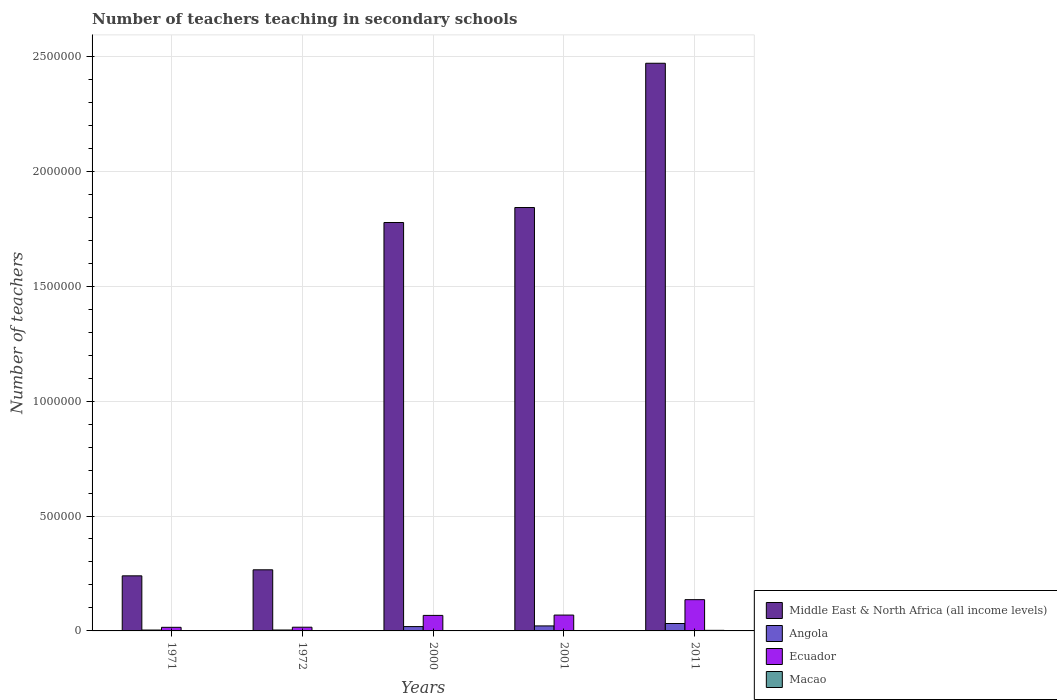How many groups of bars are there?
Provide a short and direct response. 5. Are the number of bars per tick equal to the number of legend labels?
Ensure brevity in your answer.  Yes. Are the number of bars on each tick of the X-axis equal?
Your answer should be very brief. Yes. What is the number of teachers teaching in secondary schools in Ecuador in 1971?
Your response must be concise. 1.57e+04. Across all years, what is the maximum number of teachers teaching in secondary schools in Angola?
Offer a terse response. 3.23e+04. Across all years, what is the minimum number of teachers teaching in secondary schools in Macao?
Your response must be concise. 668. In which year was the number of teachers teaching in secondary schools in Macao maximum?
Provide a short and direct response. 2011. What is the total number of teachers teaching in secondary schools in Macao in the graph?
Ensure brevity in your answer.  7018. What is the difference between the number of teachers teaching in secondary schools in Ecuador in 2001 and that in 2011?
Ensure brevity in your answer.  -6.71e+04. What is the difference between the number of teachers teaching in secondary schools in Middle East & North Africa (all income levels) in 2011 and the number of teachers teaching in secondary schools in Macao in 2000?
Your answer should be very brief. 2.47e+06. What is the average number of teachers teaching in secondary schools in Macao per year?
Keep it short and to the point. 1403.6. In the year 2001, what is the difference between the number of teachers teaching in secondary schools in Angola and number of teachers teaching in secondary schools in Ecuador?
Make the answer very short. -4.71e+04. In how many years, is the number of teachers teaching in secondary schools in Middle East & North Africa (all income levels) greater than 1300000?
Make the answer very short. 3. What is the ratio of the number of teachers teaching in secondary schools in Middle East & North Africa (all income levels) in 2000 to that in 2011?
Offer a very short reply. 0.72. Is the number of teachers teaching in secondary schools in Middle East & North Africa (all income levels) in 1971 less than that in 1972?
Give a very brief answer. Yes. What is the difference between the highest and the second highest number of teachers teaching in secondary schools in Angola?
Keep it short and to the point. 1.05e+04. What is the difference between the highest and the lowest number of teachers teaching in secondary schools in Macao?
Offer a very short reply. 1855. In how many years, is the number of teachers teaching in secondary schools in Macao greater than the average number of teachers teaching in secondary schools in Macao taken over all years?
Offer a terse response. 3. Is the sum of the number of teachers teaching in secondary schools in Ecuador in 1972 and 2011 greater than the maximum number of teachers teaching in secondary schools in Macao across all years?
Your response must be concise. Yes. Is it the case that in every year, the sum of the number of teachers teaching in secondary schools in Middle East & North Africa (all income levels) and number of teachers teaching in secondary schools in Ecuador is greater than the sum of number of teachers teaching in secondary schools in Macao and number of teachers teaching in secondary schools in Angola?
Ensure brevity in your answer.  Yes. What does the 3rd bar from the left in 1972 represents?
Keep it short and to the point. Ecuador. What does the 2nd bar from the right in 1972 represents?
Provide a succinct answer. Ecuador. How many bars are there?
Offer a very short reply. 20. Does the graph contain any zero values?
Give a very brief answer. No. Where does the legend appear in the graph?
Ensure brevity in your answer.  Bottom right. How many legend labels are there?
Make the answer very short. 4. How are the legend labels stacked?
Give a very brief answer. Vertical. What is the title of the graph?
Keep it short and to the point. Number of teachers teaching in secondary schools. What is the label or title of the X-axis?
Your answer should be compact. Years. What is the label or title of the Y-axis?
Your answer should be very brief. Number of teachers. What is the Number of teachers in Middle East & North Africa (all income levels) in 1971?
Give a very brief answer. 2.40e+05. What is the Number of teachers of Angola in 1971?
Your answer should be compact. 3814. What is the Number of teachers in Ecuador in 1971?
Give a very brief answer. 1.57e+04. What is the Number of teachers in Macao in 1971?
Make the answer very short. 725. What is the Number of teachers in Middle East & North Africa (all income levels) in 1972?
Offer a terse response. 2.66e+05. What is the Number of teachers in Angola in 1972?
Your answer should be very brief. 3987. What is the Number of teachers of Ecuador in 1972?
Make the answer very short. 1.61e+04. What is the Number of teachers of Macao in 1972?
Give a very brief answer. 668. What is the Number of teachers of Middle East & North Africa (all income levels) in 2000?
Offer a terse response. 1.78e+06. What is the Number of teachers of Angola in 2000?
Offer a terse response. 1.88e+04. What is the Number of teachers of Ecuador in 2000?
Provide a succinct answer. 6.75e+04. What is the Number of teachers of Macao in 2000?
Keep it short and to the point. 1481. What is the Number of teachers in Middle East & North Africa (all income levels) in 2001?
Offer a very short reply. 1.84e+06. What is the Number of teachers in Angola in 2001?
Your answer should be compact. 2.18e+04. What is the Number of teachers of Ecuador in 2001?
Your response must be concise. 6.90e+04. What is the Number of teachers of Macao in 2001?
Your answer should be very brief. 1621. What is the Number of teachers of Middle East & North Africa (all income levels) in 2011?
Make the answer very short. 2.47e+06. What is the Number of teachers of Angola in 2011?
Make the answer very short. 3.23e+04. What is the Number of teachers of Ecuador in 2011?
Keep it short and to the point. 1.36e+05. What is the Number of teachers in Macao in 2011?
Offer a very short reply. 2523. Across all years, what is the maximum Number of teachers of Middle East & North Africa (all income levels)?
Offer a terse response. 2.47e+06. Across all years, what is the maximum Number of teachers of Angola?
Provide a short and direct response. 3.23e+04. Across all years, what is the maximum Number of teachers in Ecuador?
Your response must be concise. 1.36e+05. Across all years, what is the maximum Number of teachers of Macao?
Ensure brevity in your answer.  2523. Across all years, what is the minimum Number of teachers in Middle East & North Africa (all income levels)?
Provide a succinct answer. 2.40e+05. Across all years, what is the minimum Number of teachers of Angola?
Keep it short and to the point. 3814. Across all years, what is the minimum Number of teachers in Ecuador?
Your answer should be compact. 1.57e+04. Across all years, what is the minimum Number of teachers in Macao?
Give a very brief answer. 668. What is the total Number of teachers of Middle East & North Africa (all income levels) in the graph?
Your response must be concise. 6.60e+06. What is the total Number of teachers in Angola in the graph?
Keep it short and to the point. 8.07e+04. What is the total Number of teachers of Ecuador in the graph?
Offer a terse response. 3.04e+05. What is the total Number of teachers in Macao in the graph?
Your response must be concise. 7018. What is the difference between the Number of teachers of Middle East & North Africa (all income levels) in 1971 and that in 1972?
Your response must be concise. -2.62e+04. What is the difference between the Number of teachers in Angola in 1971 and that in 1972?
Offer a very short reply. -173. What is the difference between the Number of teachers of Ecuador in 1971 and that in 1972?
Your answer should be very brief. -439. What is the difference between the Number of teachers in Macao in 1971 and that in 1972?
Provide a short and direct response. 57. What is the difference between the Number of teachers of Middle East & North Africa (all income levels) in 1971 and that in 2000?
Offer a terse response. -1.54e+06. What is the difference between the Number of teachers in Angola in 1971 and that in 2000?
Keep it short and to the point. -1.50e+04. What is the difference between the Number of teachers of Ecuador in 1971 and that in 2000?
Your response must be concise. -5.18e+04. What is the difference between the Number of teachers in Macao in 1971 and that in 2000?
Offer a very short reply. -756. What is the difference between the Number of teachers of Middle East & North Africa (all income levels) in 1971 and that in 2001?
Make the answer very short. -1.60e+06. What is the difference between the Number of teachers of Angola in 1971 and that in 2001?
Give a very brief answer. -1.80e+04. What is the difference between the Number of teachers in Ecuador in 1971 and that in 2001?
Offer a terse response. -5.33e+04. What is the difference between the Number of teachers in Macao in 1971 and that in 2001?
Your answer should be very brief. -896. What is the difference between the Number of teachers of Middle East & North Africa (all income levels) in 1971 and that in 2011?
Your answer should be compact. -2.23e+06. What is the difference between the Number of teachers of Angola in 1971 and that in 2011?
Your answer should be very brief. -2.85e+04. What is the difference between the Number of teachers of Ecuador in 1971 and that in 2011?
Provide a short and direct response. -1.20e+05. What is the difference between the Number of teachers in Macao in 1971 and that in 2011?
Your answer should be very brief. -1798. What is the difference between the Number of teachers of Middle East & North Africa (all income levels) in 1972 and that in 2000?
Provide a succinct answer. -1.51e+06. What is the difference between the Number of teachers in Angola in 1972 and that in 2000?
Keep it short and to the point. -1.49e+04. What is the difference between the Number of teachers of Ecuador in 1972 and that in 2000?
Give a very brief answer. -5.14e+04. What is the difference between the Number of teachers in Macao in 1972 and that in 2000?
Offer a very short reply. -813. What is the difference between the Number of teachers in Middle East & North Africa (all income levels) in 1972 and that in 2001?
Your response must be concise. -1.58e+06. What is the difference between the Number of teachers of Angola in 1972 and that in 2001?
Offer a terse response. -1.78e+04. What is the difference between the Number of teachers in Ecuador in 1972 and that in 2001?
Ensure brevity in your answer.  -5.28e+04. What is the difference between the Number of teachers in Macao in 1972 and that in 2001?
Ensure brevity in your answer.  -953. What is the difference between the Number of teachers in Middle East & North Africa (all income levels) in 1972 and that in 2011?
Keep it short and to the point. -2.20e+06. What is the difference between the Number of teachers in Angola in 1972 and that in 2011?
Provide a short and direct response. -2.83e+04. What is the difference between the Number of teachers of Ecuador in 1972 and that in 2011?
Make the answer very short. -1.20e+05. What is the difference between the Number of teachers in Macao in 1972 and that in 2011?
Your answer should be very brief. -1855. What is the difference between the Number of teachers of Middle East & North Africa (all income levels) in 2000 and that in 2001?
Give a very brief answer. -6.52e+04. What is the difference between the Number of teachers of Angola in 2000 and that in 2001?
Keep it short and to the point. -2970. What is the difference between the Number of teachers of Ecuador in 2000 and that in 2001?
Ensure brevity in your answer.  -1415. What is the difference between the Number of teachers of Macao in 2000 and that in 2001?
Provide a short and direct response. -140. What is the difference between the Number of teachers of Middle East & North Africa (all income levels) in 2000 and that in 2011?
Provide a succinct answer. -6.93e+05. What is the difference between the Number of teachers in Angola in 2000 and that in 2011?
Offer a very short reply. -1.34e+04. What is the difference between the Number of teachers of Ecuador in 2000 and that in 2011?
Your response must be concise. -6.85e+04. What is the difference between the Number of teachers of Macao in 2000 and that in 2011?
Ensure brevity in your answer.  -1042. What is the difference between the Number of teachers of Middle East & North Africa (all income levels) in 2001 and that in 2011?
Offer a very short reply. -6.28e+05. What is the difference between the Number of teachers of Angola in 2001 and that in 2011?
Your answer should be compact. -1.05e+04. What is the difference between the Number of teachers of Ecuador in 2001 and that in 2011?
Offer a very short reply. -6.71e+04. What is the difference between the Number of teachers in Macao in 2001 and that in 2011?
Your answer should be very brief. -902. What is the difference between the Number of teachers of Middle East & North Africa (all income levels) in 1971 and the Number of teachers of Angola in 1972?
Keep it short and to the point. 2.36e+05. What is the difference between the Number of teachers in Middle East & North Africa (all income levels) in 1971 and the Number of teachers in Ecuador in 1972?
Your answer should be very brief. 2.24e+05. What is the difference between the Number of teachers of Middle East & North Africa (all income levels) in 1971 and the Number of teachers of Macao in 1972?
Make the answer very short. 2.39e+05. What is the difference between the Number of teachers in Angola in 1971 and the Number of teachers in Ecuador in 1972?
Offer a very short reply. -1.23e+04. What is the difference between the Number of teachers in Angola in 1971 and the Number of teachers in Macao in 1972?
Ensure brevity in your answer.  3146. What is the difference between the Number of teachers of Ecuador in 1971 and the Number of teachers of Macao in 1972?
Your answer should be compact. 1.50e+04. What is the difference between the Number of teachers of Middle East & North Africa (all income levels) in 1971 and the Number of teachers of Angola in 2000?
Make the answer very short. 2.21e+05. What is the difference between the Number of teachers of Middle East & North Africa (all income levels) in 1971 and the Number of teachers of Ecuador in 2000?
Make the answer very short. 1.72e+05. What is the difference between the Number of teachers in Middle East & North Africa (all income levels) in 1971 and the Number of teachers in Macao in 2000?
Your answer should be very brief. 2.38e+05. What is the difference between the Number of teachers in Angola in 1971 and the Number of teachers in Ecuador in 2000?
Keep it short and to the point. -6.37e+04. What is the difference between the Number of teachers of Angola in 1971 and the Number of teachers of Macao in 2000?
Keep it short and to the point. 2333. What is the difference between the Number of teachers in Ecuador in 1971 and the Number of teachers in Macao in 2000?
Give a very brief answer. 1.42e+04. What is the difference between the Number of teachers of Middle East & North Africa (all income levels) in 1971 and the Number of teachers of Angola in 2001?
Keep it short and to the point. 2.18e+05. What is the difference between the Number of teachers of Middle East & North Africa (all income levels) in 1971 and the Number of teachers of Ecuador in 2001?
Your answer should be compact. 1.71e+05. What is the difference between the Number of teachers in Middle East & North Africa (all income levels) in 1971 and the Number of teachers in Macao in 2001?
Your answer should be compact. 2.38e+05. What is the difference between the Number of teachers in Angola in 1971 and the Number of teachers in Ecuador in 2001?
Your answer should be very brief. -6.51e+04. What is the difference between the Number of teachers in Angola in 1971 and the Number of teachers in Macao in 2001?
Keep it short and to the point. 2193. What is the difference between the Number of teachers of Ecuador in 1971 and the Number of teachers of Macao in 2001?
Give a very brief answer. 1.41e+04. What is the difference between the Number of teachers of Middle East & North Africa (all income levels) in 1971 and the Number of teachers of Angola in 2011?
Ensure brevity in your answer.  2.07e+05. What is the difference between the Number of teachers in Middle East & North Africa (all income levels) in 1971 and the Number of teachers in Ecuador in 2011?
Provide a succinct answer. 1.04e+05. What is the difference between the Number of teachers in Middle East & North Africa (all income levels) in 1971 and the Number of teachers in Macao in 2011?
Your response must be concise. 2.37e+05. What is the difference between the Number of teachers in Angola in 1971 and the Number of teachers in Ecuador in 2011?
Offer a very short reply. -1.32e+05. What is the difference between the Number of teachers of Angola in 1971 and the Number of teachers of Macao in 2011?
Your response must be concise. 1291. What is the difference between the Number of teachers in Ecuador in 1971 and the Number of teachers in Macao in 2011?
Ensure brevity in your answer.  1.32e+04. What is the difference between the Number of teachers of Middle East & North Africa (all income levels) in 1972 and the Number of teachers of Angola in 2000?
Offer a terse response. 2.47e+05. What is the difference between the Number of teachers of Middle East & North Africa (all income levels) in 1972 and the Number of teachers of Ecuador in 2000?
Offer a very short reply. 1.98e+05. What is the difference between the Number of teachers in Middle East & North Africa (all income levels) in 1972 and the Number of teachers in Macao in 2000?
Provide a short and direct response. 2.64e+05. What is the difference between the Number of teachers in Angola in 1972 and the Number of teachers in Ecuador in 2000?
Ensure brevity in your answer.  -6.36e+04. What is the difference between the Number of teachers of Angola in 1972 and the Number of teachers of Macao in 2000?
Ensure brevity in your answer.  2506. What is the difference between the Number of teachers of Ecuador in 1972 and the Number of teachers of Macao in 2000?
Give a very brief answer. 1.47e+04. What is the difference between the Number of teachers in Middle East & North Africa (all income levels) in 1972 and the Number of teachers in Angola in 2001?
Your response must be concise. 2.44e+05. What is the difference between the Number of teachers in Middle East & North Africa (all income levels) in 1972 and the Number of teachers in Ecuador in 2001?
Your response must be concise. 1.97e+05. What is the difference between the Number of teachers of Middle East & North Africa (all income levels) in 1972 and the Number of teachers of Macao in 2001?
Provide a short and direct response. 2.64e+05. What is the difference between the Number of teachers in Angola in 1972 and the Number of teachers in Ecuador in 2001?
Keep it short and to the point. -6.50e+04. What is the difference between the Number of teachers of Angola in 1972 and the Number of teachers of Macao in 2001?
Provide a short and direct response. 2366. What is the difference between the Number of teachers in Ecuador in 1972 and the Number of teachers in Macao in 2001?
Your answer should be compact. 1.45e+04. What is the difference between the Number of teachers in Middle East & North Africa (all income levels) in 1972 and the Number of teachers in Angola in 2011?
Ensure brevity in your answer.  2.34e+05. What is the difference between the Number of teachers in Middle East & North Africa (all income levels) in 1972 and the Number of teachers in Ecuador in 2011?
Make the answer very short. 1.30e+05. What is the difference between the Number of teachers in Middle East & North Africa (all income levels) in 1972 and the Number of teachers in Macao in 2011?
Provide a short and direct response. 2.63e+05. What is the difference between the Number of teachers in Angola in 1972 and the Number of teachers in Ecuador in 2011?
Your response must be concise. -1.32e+05. What is the difference between the Number of teachers of Angola in 1972 and the Number of teachers of Macao in 2011?
Make the answer very short. 1464. What is the difference between the Number of teachers of Ecuador in 1972 and the Number of teachers of Macao in 2011?
Ensure brevity in your answer.  1.36e+04. What is the difference between the Number of teachers of Middle East & North Africa (all income levels) in 2000 and the Number of teachers of Angola in 2001?
Your answer should be very brief. 1.76e+06. What is the difference between the Number of teachers in Middle East & North Africa (all income levels) in 2000 and the Number of teachers in Ecuador in 2001?
Offer a terse response. 1.71e+06. What is the difference between the Number of teachers of Middle East & North Africa (all income levels) in 2000 and the Number of teachers of Macao in 2001?
Provide a succinct answer. 1.78e+06. What is the difference between the Number of teachers of Angola in 2000 and the Number of teachers of Ecuador in 2001?
Provide a short and direct response. -5.01e+04. What is the difference between the Number of teachers of Angola in 2000 and the Number of teachers of Macao in 2001?
Ensure brevity in your answer.  1.72e+04. What is the difference between the Number of teachers of Ecuador in 2000 and the Number of teachers of Macao in 2001?
Your answer should be compact. 6.59e+04. What is the difference between the Number of teachers in Middle East & North Africa (all income levels) in 2000 and the Number of teachers in Angola in 2011?
Your answer should be very brief. 1.74e+06. What is the difference between the Number of teachers of Middle East & North Africa (all income levels) in 2000 and the Number of teachers of Ecuador in 2011?
Make the answer very short. 1.64e+06. What is the difference between the Number of teachers of Middle East & North Africa (all income levels) in 2000 and the Number of teachers of Macao in 2011?
Make the answer very short. 1.77e+06. What is the difference between the Number of teachers in Angola in 2000 and the Number of teachers in Ecuador in 2011?
Make the answer very short. -1.17e+05. What is the difference between the Number of teachers of Angola in 2000 and the Number of teachers of Macao in 2011?
Make the answer very short. 1.63e+04. What is the difference between the Number of teachers in Ecuador in 2000 and the Number of teachers in Macao in 2011?
Make the answer very short. 6.50e+04. What is the difference between the Number of teachers in Middle East & North Africa (all income levels) in 2001 and the Number of teachers in Angola in 2011?
Provide a short and direct response. 1.81e+06. What is the difference between the Number of teachers in Middle East & North Africa (all income levels) in 2001 and the Number of teachers in Ecuador in 2011?
Keep it short and to the point. 1.71e+06. What is the difference between the Number of teachers of Middle East & North Africa (all income levels) in 2001 and the Number of teachers of Macao in 2011?
Your answer should be very brief. 1.84e+06. What is the difference between the Number of teachers in Angola in 2001 and the Number of teachers in Ecuador in 2011?
Your answer should be very brief. -1.14e+05. What is the difference between the Number of teachers of Angola in 2001 and the Number of teachers of Macao in 2011?
Your response must be concise. 1.93e+04. What is the difference between the Number of teachers in Ecuador in 2001 and the Number of teachers in Macao in 2011?
Provide a succinct answer. 6.64e+04. What is the average Number of teachers in Middle East & North Africa (all income levels) per year?
Make the answer very short. 1.32e+06. What is the average Number of teachers in Angola per year?
Your answer should be very brief. 1.61e+04. What is the average Number of teachers in Ecuador per year?
Offer a very short reply. 6.09e+04. What is the average Number of teachers of Macao per year?
Provide a short and direct response. 1403.6. In the year 1971, what is the difference between the Number of teachers of Middle East & North Africa (all income levels) and Number of teachers of Angola?
Make the answer very short. 2.36e+05. In the year 1971, what is the difference between the Number of teachers in Middle East & North Africa (all income levels) and Number of teachers in Ecuador?
Provide a succinct answer. 2.24e+05. In the year 1971, what is the difference between the Number of teachers of Middle East & North Africa (all income levels) and Number of teachers of Macao?
Offer a very short reply. 2.39e+05. In the year 1971, what is the difference between the Number of teachers of Angola and Number of teachers of Ecuador?
Make the answer very short. -1.19e+04. In the year 1971, what is the difference between the Number of teachers in Angola and Number of teachers in Macao?
Make the answer very short. 3089. In the year 1971, what is the difference between the Number of teachers of Ecuador and Number of teachers of Macao?
Offer a very short reply. 1.50e+04. In the year 1972, what is the difference between the Number of teachers of Middle East & North Africa (all income levels) and Number of teachers of Angola?
Your response must be concise. 2.62e+05. In the year 1972, what is the difference between the Number of teachers in Middle East & North Africa (all income levels) and Number of teachers in Ecuador?
Offer a very short reply. 2.50e+05. In the year 1972, what is the difference between the Number of teachers of Middle East & North Africa (all income levels) and Number of teachers of Macao?
Your answer should be very brief. 2.65e+05. In the year 1972, what is the difference between the Number of teachers in Angola and Number of teachers in Ecuador?
Provide a succinct answer. -1.22e+04. In the year 1972, what is the difference between the Number of teachers of Angola and Number of teachers of Macao?
Provide a short and direct response. 3319. In the year 1972, what is the difference between the Number of teachers in Ecuador and Number of teachers in Macao?
Your response must be concise. 1.55e+04. In the year 2000, what is the difference between the Number of teachers in Middle East & North Africa (all income levels) and Number of teachers in Angola?
Offer a terse response. 1.76e+06. In the year 2000, what is the difference between the Number of teachers in Middle East & North Africa (all income levels) and Number of teachers in Ecuador?
Give a very brief answer. 1.71e+06. In the year 2000, what is the difference between the Number of teachers of Middle East & North Africa (all income levels) and Number of teachers of Macao?
Provide a short and direct response. 1.78e+06. In the year 2000, what is the difference between the Number of teachers of Angola and Number of teachers of Ecuador?
Your answer should be compact. -4.87e+04. In the year 2000, what is the difference between the Number of teachers in Angola and Number of teachers in Macao?
Provide a short and direct response. 1.74e+04. In the year 2000, what is the difference between the Number of teachers of Ecuador and Number of teachers of Macao?
Offer a very short reply. 6.61e+04. In the year 2001, what is the difference between the Number of teachers of Middle East & North Africa (all income levels) and Number of teachers of Angola?
Your answer should be compact. 1.82e+06. In the year 2001, what is the difference between the Number of teachers of Middle East & North Africa (all income levels) and Number of teachers of Ecuador?
Your response must be concise. 1.77e+06. In the year 2001, what is the difference between the Number of teachers of Middle East & North Africa (all income levels) and Number of teachers of Macao?
Provide a short and direct response. 1.84e+06. In the year 2001, what is the difference between the Number of teachers of Angola and Number of teachers of Ecuador?
Offer a very short reply. -4.71e+04. In the year 2001, what is the difference between the Number of teachers in Angola and Number of teachers in Macao?
Provide a short and direct response. 2.02e+04. In the year 2001, what is the difference between the Number of teachers in Ecuador and Number of teachers in Macao?
Give a very brief answer. 6.73e+04. In the year 2011, what is the difference between the Number of teachers in Middle East & North Africa (all income levels) and Number of teachers in Angola?
Make the answer very short. 2.44e+06. In the year 2011, what is the difference between the Number of teachers in Middle East & North Africa (all income levels) and Number of teachers in Ecuador?
Your answer should be very brief. 2.33e+06. In the year 2011, what is the difference between the Number of teachers in Middle East & North Africa (all income levels) and Number of teachers in Macao?
Offer a very short reply. 2.47e+06. In the year 2011, what is the difference between the Number of teachers in Angola and Number of teachers in Ecuador?
Give a very brief answer. -1.04e+05. In the year 2011, what is the difference between the Number of teachers of Angola and Number of teachers of Macao?
Give a very brief answer. 2.98e+04. In the year 2011, what is the difference between the Number of teachers of Ecuador and Number of teachers of Macao?
Provide a succinct answer. 1.33e+05. What is the ratio of the Number of teachers in Middle East & North Africa (all income levels) in 1971 to that in 1972?
Your response must be concise. 0.9. What is the ratio of the Number of teachers of Angola in 1971 to that in 1972?
Give a very brief answer. 0.96. What is the ratio of the Number of teachers of Ecuador in 1971 to that in 1972?
Give a very brief answer. 0.97. What is the ratio of the Number of teachers in Macao in 1971 to that in 1972?
Make the answer very short. 1.09. What is the ratio of the Number of teachers of Middle East & North Africa (all income levels) in 1971 to that in 2000?
Provide a succinct answer. 0.13. What is the ratio of the Number of teachers of Angola in 1971 to that in 2000?
Your answer should be very brief. 0.2. What is the ratio of the Number of teachers in Ecuador in 1971 to that in 2000?
Provide a short and direct response. 0.23. What is the ratio of the Number of teachers in Macao in 1971 to that in 2000?
Your answer should be compact. 0.49. What is the ratio of the Number of teachers of Middle East & North Africa (all income levels) in 1971 to that in 2001?
Keep it short and to the point. 0.13. What is the ratio of the Number of teachers of Angola in 1971 to that in 2001?
Offer a terse response. 0.17. What is the ratio of the Number of teachers in Ecuador in 1971 to that in 2001?
Offer a very short reply. 0.23. What is the ratio of the Number of teachers in Macao in 1971 to that in 2001?
Provide a succinct answer. 0.45. What is the ratio of the Number of teachers of Middle East & North Africa (all income levels) in 1971 to that in 2011?
Offer a very short reply. 0.1. What is the ratio of the Number of teachers of Angola in 1971 to that in 2011?
Make the answer very short. 0.12. What is the ratio of the Number of teachers of Ecuador in 1971 to that in 2011?
Your answer should be compact. 0.12. What is the ratio of the Number of teachers of Macao in 1971 to that in 2011?
Provide a succinct answer. 0.29. What is the ratio of the Number of teachers of Middle East & North Africa (all income levels) in 1972 to that in 2000?
Offer a very short reply. 0.15. What is the ratio of the Number of teachers in Angola in 1972 to that in 2000?
Your answer should be very brief. 0.21. What is the ratio of the Number of teachers of Ecuador in 1972 to that in 2000?
Offer a terse response. 0.24. What is the ratio of the Number of teachers in Macao in 1972 to that in 2000?
Make the answer very short. 0.45. What is the ratio of the Number of teachers in Middle East & North Africa (all income levels) in 1972 to that in 2001?
Your answer should be very brief. 0.14. What is the ratio of the Number of teachers in Angola in 1972 to that in 2001?
Provide a succinct answer. 0.18. What is the ratio of the Number of teachers of Ecuador in 1972 to that in 2001?
Ensure brevity in your answer.  0.23. What is the ratio of the Number of teachers in Macao in 1972 to that in 2001?
Make the answer very short. 0.41. What is the ratio of the Number of teachers of Middle East & North Africa (all income levels) in 1972 to that in 2011?
Your answer should be very brief. 0.11. What is the ratio of the Number of teachers in Angola in 1972 to that in 2011?
Give a very brief answer. 0.12. What is the ratio of the Number of teachers in Ecuador in 1972 to that in 2011?
Ensure brevity in your answer.  0.12. What is the ratio of the Number of teachers in Macao in 1972 to that in 2011?
Give a very brief answer. 0.26. What is the ratio of the Number of teachers in Middle East & North Africa (all income levels) in 2000 to that in 2001?
Ensure brevity in your answer.  0.96. What is the ratio of the Number of teachers in Angola in 2000 to that in 2001?
Provide a short and direct response. 0.86. What is the ratio of the Number of teachers in Ecuador in 2000 to that in 2001?
Ensure brevity in your answer.  0.98. What is the ratio of the Number of teachers of Macao in 2000 to that in 2001?
Provide a short and direct response. 0.91. What is the ratio of the Number of teachers of Middle East & North Africa (all income levels) in 2000 to that in 2011?
Offer a very short reply. 0.72. What is the ratio of the Number of teachers of Angola in 2000 to that in 2011?
Ensure brevity in your answer.  0.58. What is the ratio of the Number of teachers of Ecuador in 2000 to that in 2011?
Offer a very short reply. 0.5. What is the ratio of the Number of teachers in Macao in 2000 to that in 2011?
Provide a short and direct response. 0.59. What is the ratio of the Number of teachers in Middle East & North Africa (all income levels) in 2001 to that in 2011?
Offer a very short reply. 0.75. What is the ratio of the Number of teachers in Angola in 2001 to that in 2011?
Offer a terse response. 0.68. What is the ratio of the Number of teachers in Ecuador in 2001 to that in 2011?
Make the answer very short. 0.51. What is the ratio of the Number of teachers of Macao in 2001 to that in 2011?
Your answer should be compact. 0.64. What is the difference between the highest and the second highest Number of teachers of Middle East & North Africa (all income levels)?
Your answer should be compact. 6.28e+05. What is the difference between the highest and the second highest Number of teachers of Angola?
Ensure brevity in your answer.  1.05e+04. What is the difference between the highest and the second highest Number of teachers in Ecuador?
Your response must be concise. 6.71e+04. What is the difference between the highest and the second highest Number of teachers in Macao?
Ensure brevity in your answer.  902. What is the difference between the highest and the lowest Number of teachers in Middle East & North Africa (all income levels)?
Make the answer very short. 2.23e+06. What is the difference between the highest and the lowest Number of teachers in Angola?
Your answer should be compact. 2.85e+04. What is the difference between the highest and the lowest Number of teachers of Ecuador?
Provide a short and direct response. 1.20e+05. What is the difference between the highest and the lowest Number of teachers of Macao?
Your answer should be very brief. 1855. 